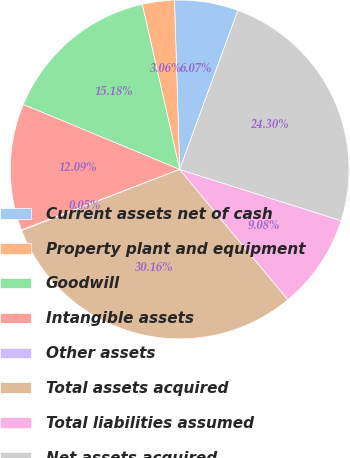<chart> <loc_0><loc_0><loc_500><loc_500><pie_chart><fcel>Current assets net of cash<fcel>Property plant and equipment<fcel>Goodwill<fcel>Intangible assets<fcel>Other assets<fcel>Total assets acquired<fcel>Total liabilities assumed<fcel>Net assets acquired<nl><fcel>6.07%<fcel>3.06%<fcel>15.18%<fcel>12.09%<fcel>0.05%<fcel>30.16%<fcel>9.08%<fcel>24.3%<nl></chart> 